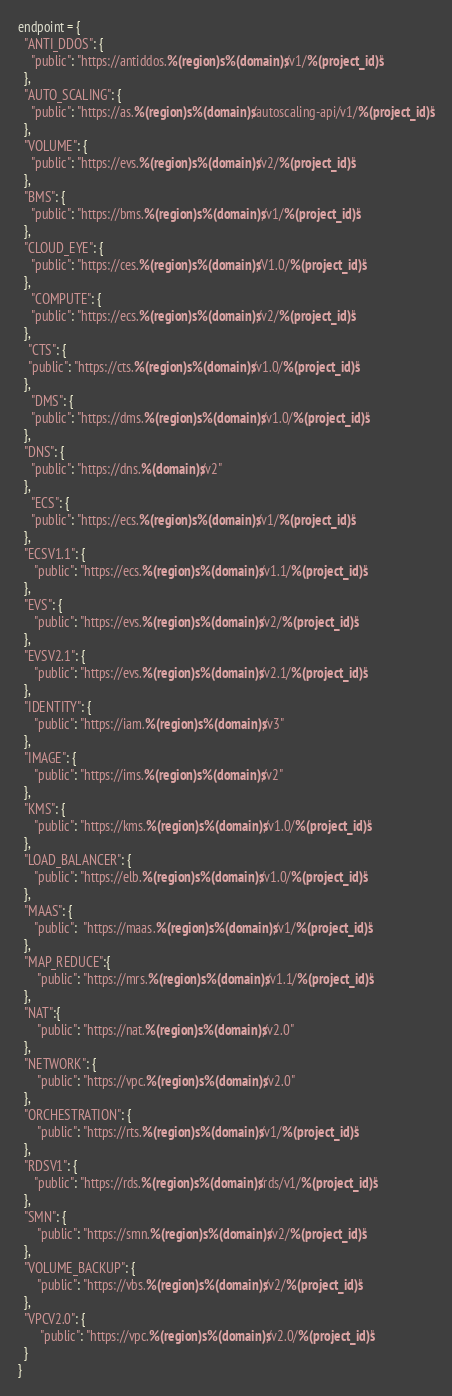Convert code to text. <code><loc_0><loc_0><loc_500><loc_500><_Python_>endpoint = {
  "ANTI_DDOS": {
    "public": "https://antiddos.%(region)s.%(domain)s/v1/%(project_id)s"
  },
  "AUTO_SCALING": {
    "public": "https://as.%(region)s.%(domain)s/autoscaling-api/v1/%(project_id)s"
  },
  "VOLUME": {
    "public": "https://evs.%(region)s.%(domain)s/v2/%(project_id)s"
  },
  "BMS": {
    "public": "https://bms.%(region)s.%(domain)s/v1/%(project_id)s"
  },
  "CLOUD_EYE": {
    "public": "https://ces.%(region)s.%(domain)s/V1.0/%(project_id)s"
  },
    "COMPUTE": {
    "public": "https://ecs.%(region)s.%(domain)s/v2/%(project_id)s"
  },
   "CTS": {
   "public": "https://cts.%(region)s.%(domain)s/v1.0/%(project_id)s"
  },
    "DMS": {
    "public": "https://dms.%(region)s.%(domain)s/v1.0/%(project_id)s"
  },
  "DNS": {
    "public": "https://dns.%(domain)s/v2"
  },
    "ECS": {
    "public": "https://ecs.%(region)s.%(domain)s/v1/%(project_id)s"
  },
  "ECSV1.1": {
     "public": "https://ecs.%(region)s.%(domain)s/v1.1/%(project_id)s"
  },
  "EVS": {
     "public": "https://evs.%(region)s.%(domain)s/v2/%(project_id)s"
  },
  "EVSV2.1": {
     "public": "https://evs.%(region)s.%(domain)s/v2.1/%(project_id)s"
  },
  "IDENTITY": {
     "public": "https://iam.%(region)s.%(domain)s/v3"
  },
  "IMAGE": {
     "public": "https://ims.%(region)s.%(domain)s/v2"
  },
  "KMS": {
     "public": "https://kms.%(region)s.%(domain)s/v1.0/%(project_id)s"
  },
  "LOAD_BALANCER": {
     "public": "https://elb.%(region)s.%(domain)s/v1.0/%(project_id)s"
  },
  "MAAS": {
     "public":  "https://maas.%(region)s.%(domain)s/v1/%(project_id)s"
  },
  "MAP_REDUCE":{
      "public": "https://mrs.%(region)s.%(domain)s/v1.1/%(project_id)s"
  },
  "NAT":{
      "public": "https://nat.%(region)s.%(domain)s/v2.0"
  },
  "NETWORK": {
      "public": "https://vpc.%(region)s.%(domain)s/v2.0"
  },
  "ORCHESTRATION": {
      "public": "https://rts.%(region)s.%(domain)s/v1/%(project_id)s"
  },
  "RDSV1": {
     "public": "https://rds.%(region)s.%(domain)s/rds/v1/%(project_id)s"
  },
  "SMN": {
      "public": "https://smn.%(region)s.%(domain)s/v2/%(project_id)s"
  },
  "VOLUME_BACKUP": {
      "public": "https://vbs.%(region)s.%(domain)s/v2/%(project_id)s"
  },
  "VPCV2.0": {
       "public": "https://vpc.%(region)s.%(domain)s/v2.0/%(project_id)s"
  }
}
</code> 